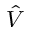<formula> <loc_0><loc_0><loc_500><loc_500>\hat { V }</formula> 